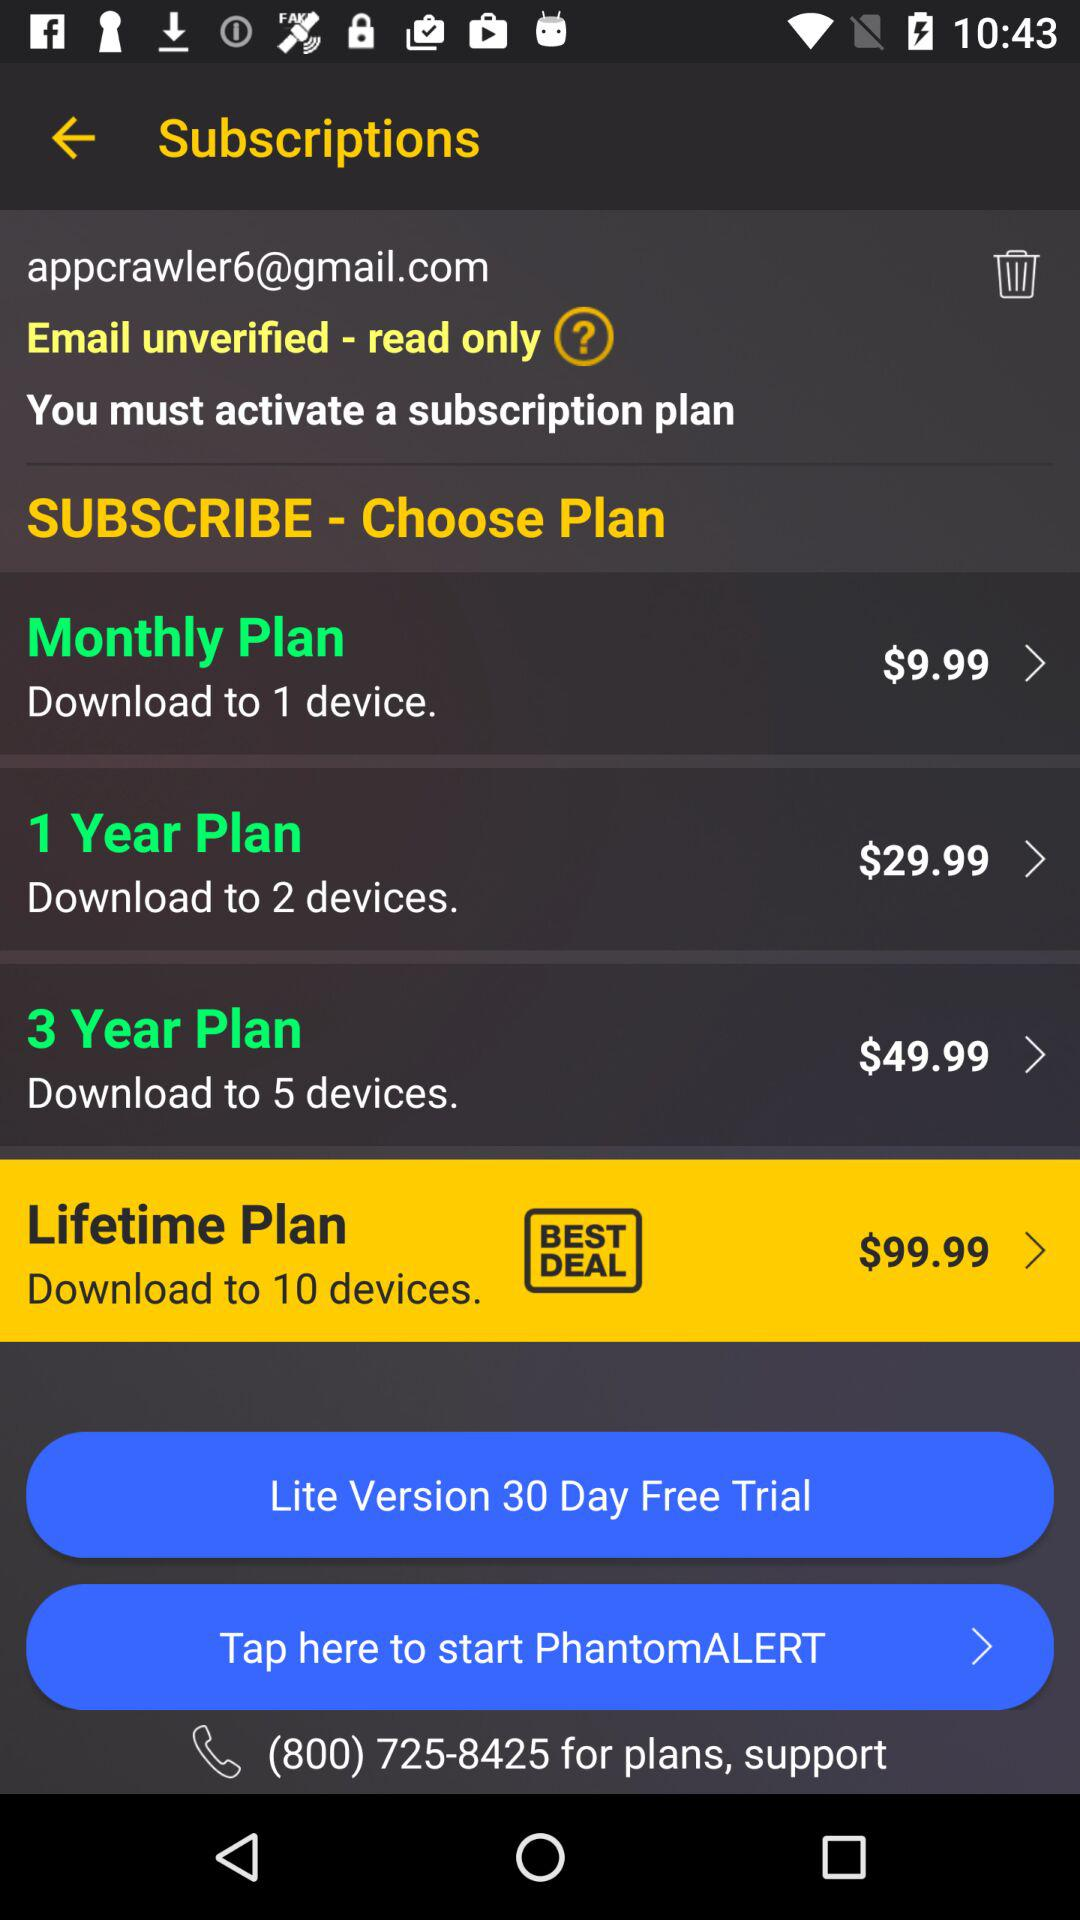What is the price of the "MONTHLY PLAN"? The price of the "MONTHLY PLAN" is $9.99. 